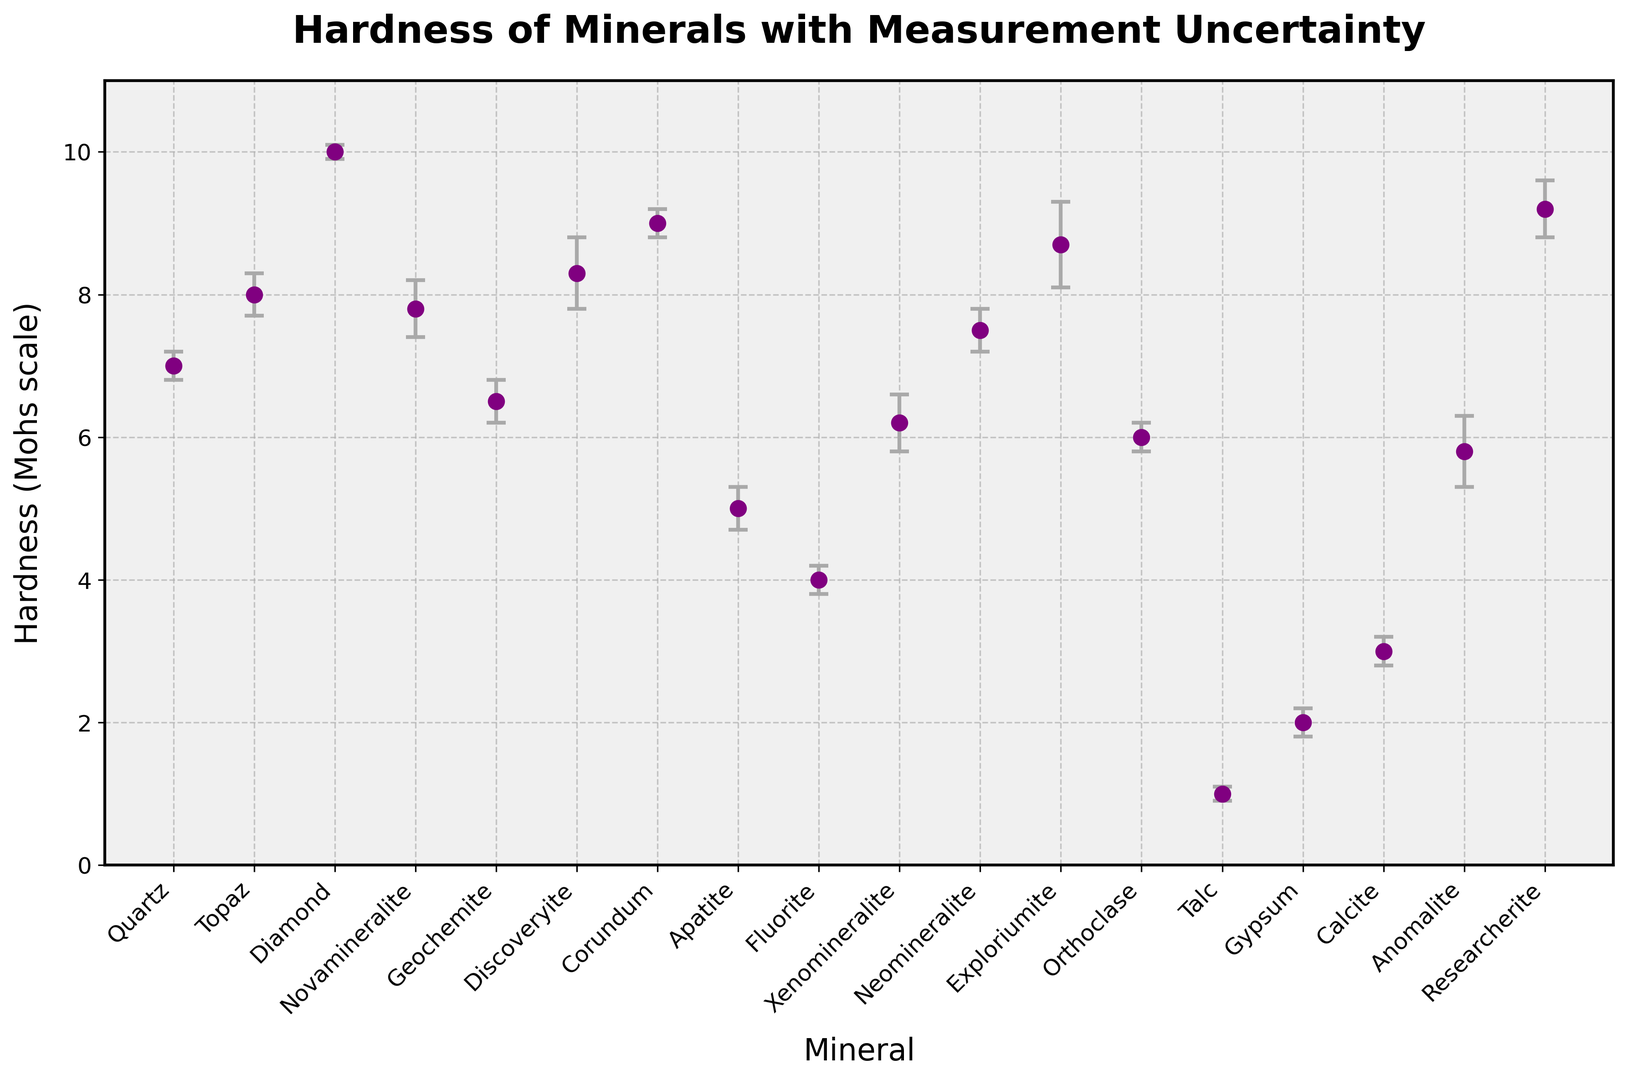Which mineral has the highest hardness measurement? The mineral with the highest hardness measurement can be identified by visually inspecting the plot and looking for the highest data point on the y-axis.
Answer: Diamond Which two minerals have hardness measurements closest to each other, excluding error bars? To find the closest hardness measurements, visually compare the data points on the y-axis and identify which two are the closest in value.
Answer: Quartz and Neomineralite How does the hardness of Novamineralite compare to Topaz? By examining the plot, compare the y-values of Novamineralite and Topaz, noting Novamineralite slightly below Topaz.
Answer: Novamineralite is slightly less hard than Topaz What is the approximate average hardness of the minerals Quartz, Topaz, and Diamond? Add the hardness values of Quartz (7.0), Topaz (8.0), and Diamond (10.0) and divide by 3 to get the average: (7.0 + 8.0 + 10.0) / 3.
Answer: 8.33 Which mineral has the greatest measurement uncertainty? Identify the mineral with the longest error bar by examining the length of the vertical lines extending from each data point.
Answer: Exploriumite Are there any minerals with a hardness of 6.0 or lower but with an uncertainty above 0.3 units? Check the minerals with hardness 6.0 or lower and examine their error bars. Identify those with errors above 0.3.
Answer: Xenomineralite and Anomalite What is the range of hardness values for all minerals shown? Identify the lowest (Talc = 1.0) and highest (Diamond = 10.0) hardness values, then calculate the range: 10.0 - 1.0.
Answer: 9.0 Which novel mineral has the highest hardness value? Compare the y-values of the novel minerals: Novamineralite, Geochemite, Discoveryite, Xenomineralite, Neomineralite, Exploriumite, Anomalite, Researcherite and identify the highest.
Answer: Researcherite 